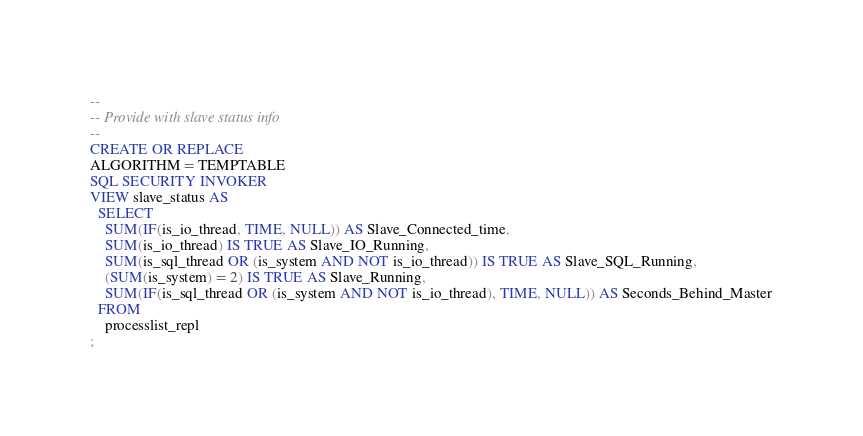Convert code to text. <code><loc_0><loc_0><loc_500><loc_500><_SQL_>-- 
-- Provide with slave status info
-- 
CREATE OR REPLACE
ALGORITHM = TEMPTABLE
SQL SECURITY INVOKER
VIEW slave_status AS
  SELECT 
    SUM(IF(is_io_thread, TIME, NULL)) AS Slave_Connected_time,
    SUM(is_io_thread) IS TRUE AS Slave_IO_Running,
    SUM(is_sql_thread OR (is_system AND NOT is_io_thread)) IS TRUE AS Slave_SQL_Running,
    (SUM(is_system) = 2) IS TRUE AS Slave_Running,
    SUM(IF(is_sql_thread OR (is_system AND NOT is_io_thread), TIME, NULL)) AS Seconds_Behind_Master
  FROM 
    processlist_repl
;
</code> 